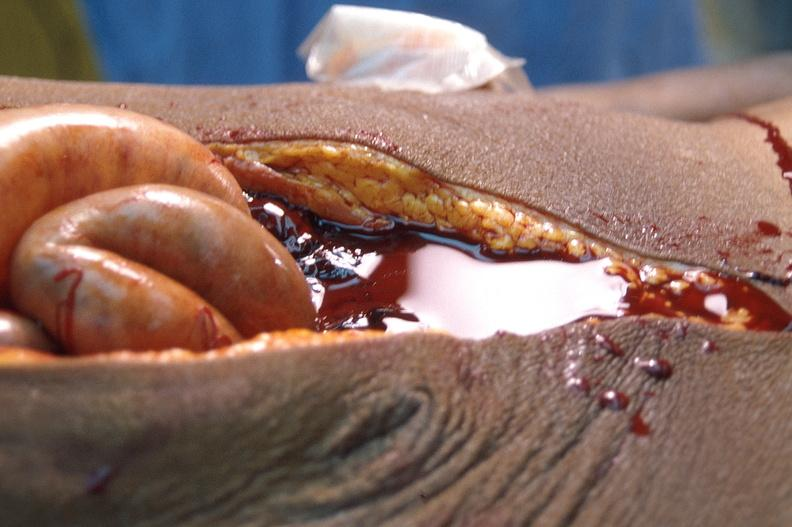s slices of liver and spleen typical tuberculous exudate is present on capsule of liver and spleen present?
Answer the question using a single word or phrase. No 